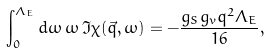<formula> <loc_0><loc_0><loc_500><loc_500>\int _ { 0 } ^ { \Lambda _ { E } } d \omega \, \omega \, \Im \chi ( \vec { q } , \omega ) = - \frac { g _ { S } g _ { v } q ^ { 2 } \Lambda _ { E } } { 1 6 } ,</formula> 